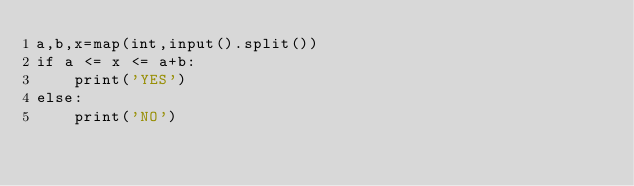<code> <loc_0><loc_0><loc_500><loc_500><_Python_>a,b,x=map(int,input().split())
if a <= x <= a+b:
	print('YES')
else:
	print('NO')
</code> 